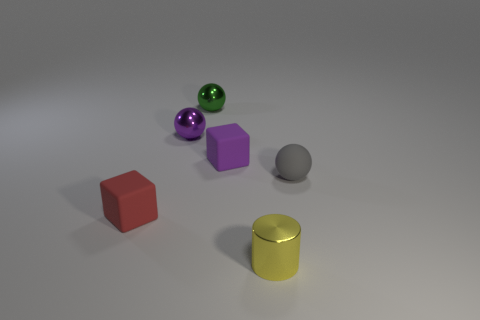There is a matte object that is both left of the yellow shiny thing and behind the red block; what shape is it?
Provide a succinct answer. Cube. Are there an equal number of tiny matte things that are to the right of the small gray matte ball and small purple spheres on the left side of the green metal sphere?
Your response must be concise. No. Does the red rubber thing left of the yellow cylinder have the same shape as the green thing?
Provide a succinct answer. No. What number of red things are either rubber blocks or tiny objects?
Offer a very short reply. 1. There is a purple thing that is the same shape as the tiny gray thing; what is it made of?
Your answer should be very brief. Metal. What is the shape of the small metallic thing that is in front of the red block?
Keep it short and to the point. Cylinder. Are there any tiny balls that have the same material as the tiny red thing?
Keep it short and to the point. Yes. Is the metallic cylinder the same size as the red cube?
Ensure brevity in your answer.  Yes. What number of balls are either purple metallic objects or small gray matte objects?
Provide a succinct answer. 2. What number of other small objects are the same shape as the small red rubber object?
Your response must be concise. 1. 